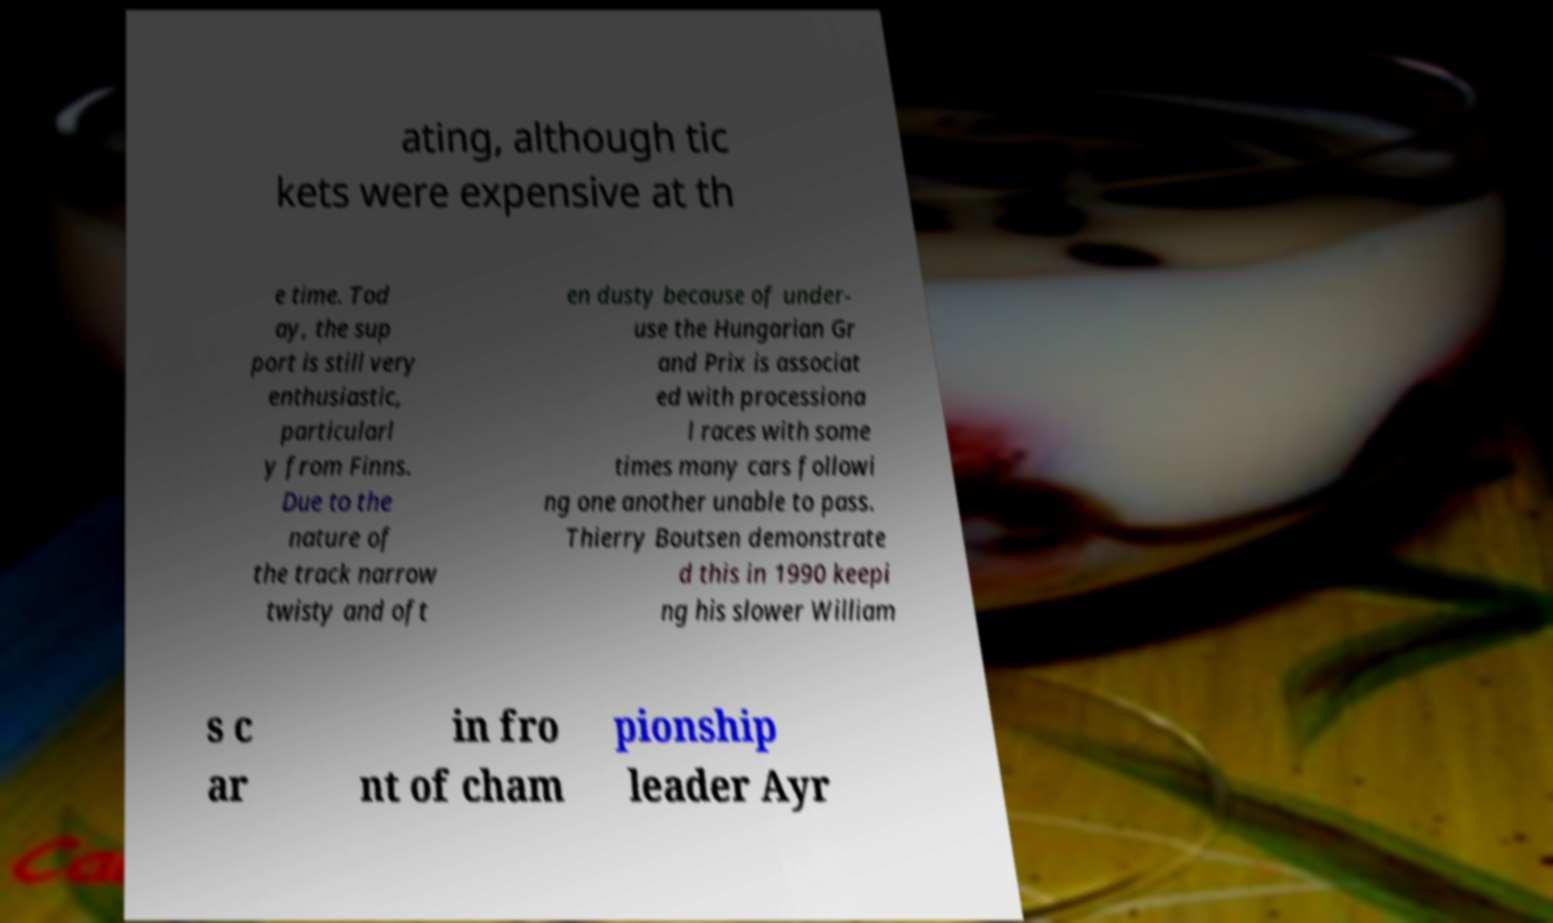Please identify and transcribe the text found in this image. ating, although tic kets were expensive at th e time. Tod ay, the sup port is still very enthusiastic, particularl y from Finns. Due to the nature of the track narrow twisty and oft en dusty because of under- use the Hungarian Gr and Prix is associat ed with processiona l races with some times many cars followi ng one another unable to pass. Thierry Boutsen demonstrate d this in 1990 keepi ng his slower William s c ar in fro nt of cham pionship leader Ayr 